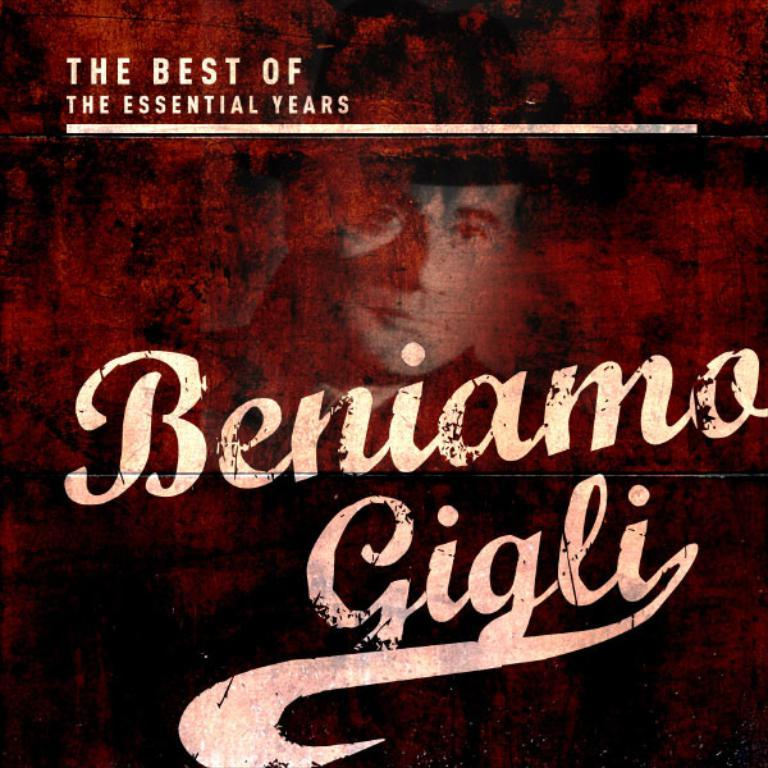Provide a one-sentence caption for the provided image. An album compilation of Beniamo Gigli that is from the essential years. 